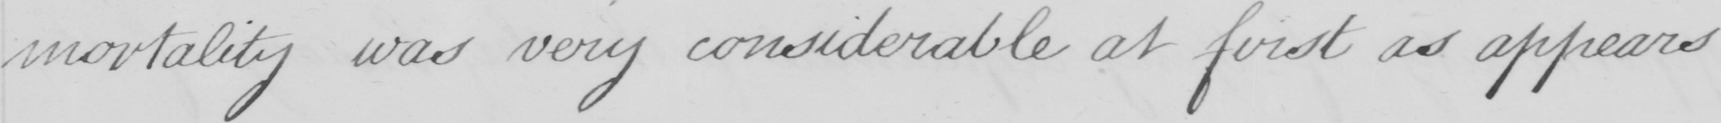Can you tell me what this handwritten text says? mortality was very considerable at first as appears 